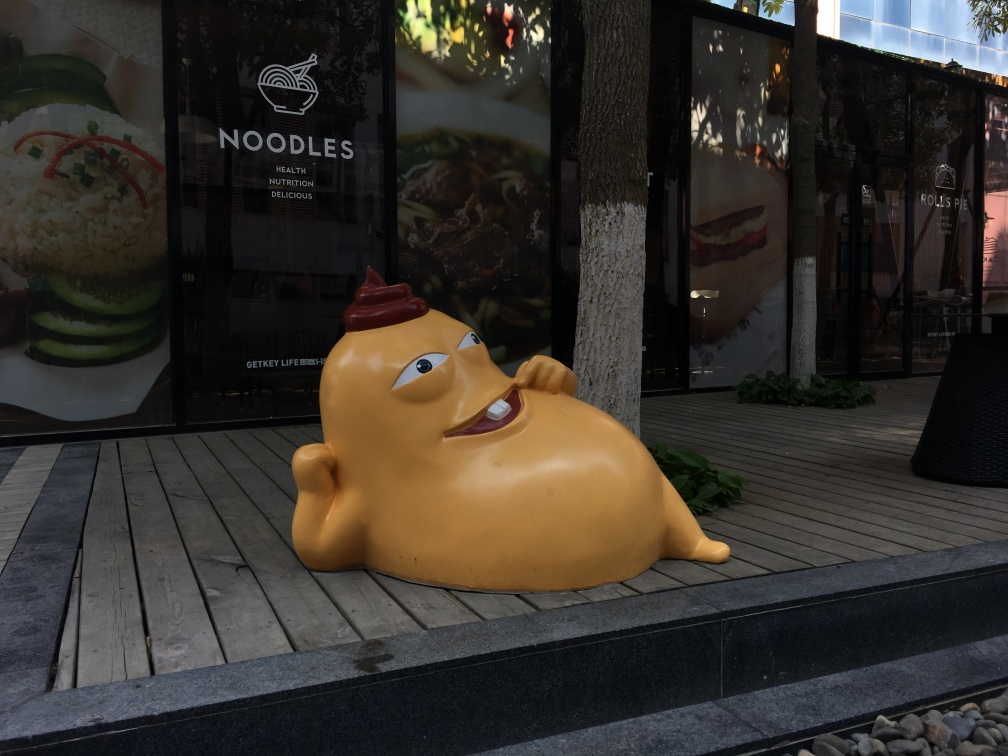How do the aesthetics of this sculpture contribute to the ambiance of the area? The sculpture's oversized, cartoonish features and bright colors add a touch of humor and light-heartedness to the environment. Its laid-back pose and the welcoming smile might evoke feelings of relaxation and playfulness in an otherwise ordinary urban setting. What can you say about the design and functionality of this outdoor space? The outdoor space has been designed with both aesthetic appeal and functionality in mind. The wooden deck creates a clear pathway for pedestrians, while the sculpture serves as an eye-catching centerpiece. The contrasting textures of the wood, glass, and shaded seating areas provide a visually interesting environment that invites passersby to linger and perhaps enjoy a meal from the nearby eateries. 